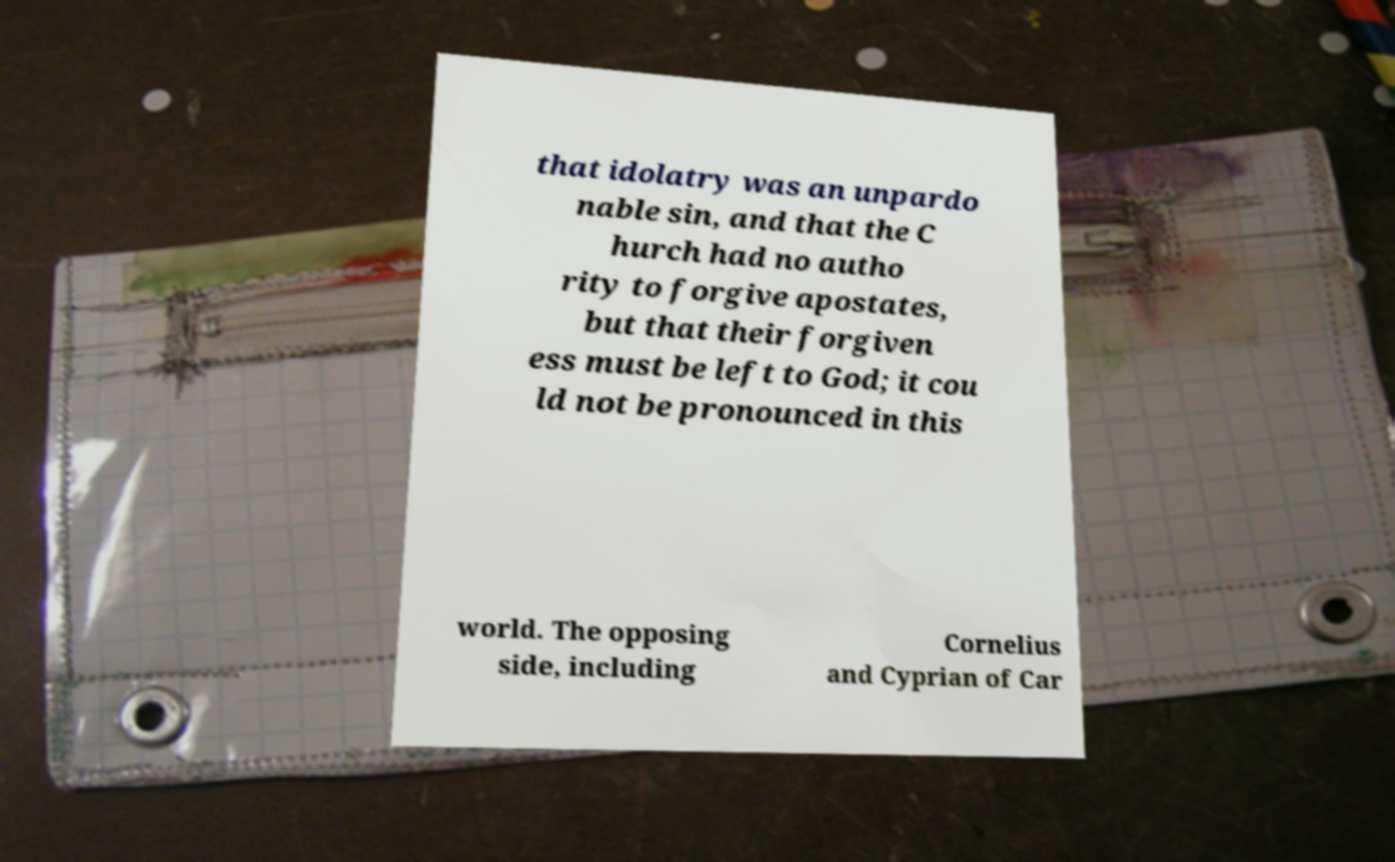For documentation purposes, I need the text within this image transcribed. Could you provide that? that idolatry was an unpardo nable sin, and that the C hurch had no autho rity to forgive apostates, but that their forgiven ess must be left to God; it cou ld not be pronounced in this world. The opposing side, including Cornelius and Cyprian of Car 